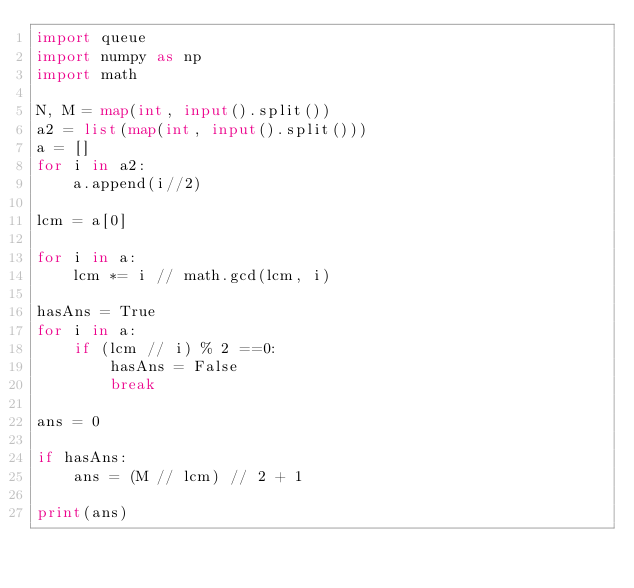<code> <loc_0><loc_0><loc_500><loc_500><_Python_>import queue
import numpy as np
import math

N, M = map(int, input().split())
a2 = list(map(int, input().split()))
a = []
for i in a2:
    a.append(i//2)

lcm = a[0]

for i in a:
    lcm *= i // math.gcd(lcm, i)

hasAns = True
for i in a:
    if (lcm // i) % 2 ==0:
        hasAns = False
        break

ans = 0

if hasAns:
    ans = (M // lcm) // 2 + 1

print(ans)</code> 